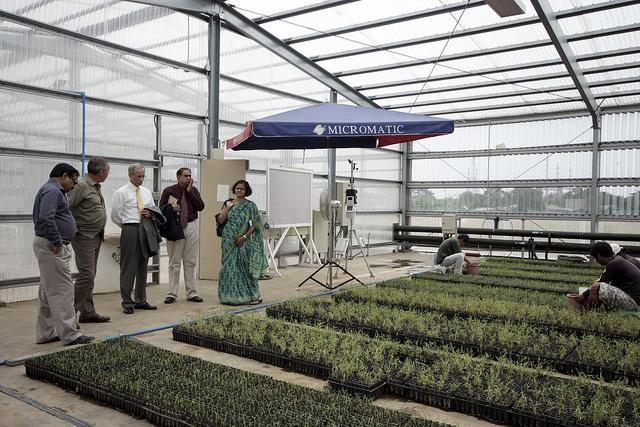What might the temperature be like where they are standing? warm 